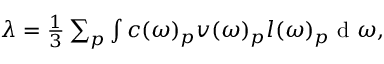<formula> <loc_0><loc_0><loc_500><loc_500>\begin{array} { r } { \lambda = \frac { 1 } { 3 } \sum _ { p } \int c ( \omega ) _ { p } v ( \omega ) _ { p } l ( \omega ) _ { p } d \omega , } \end{array}</formula> 